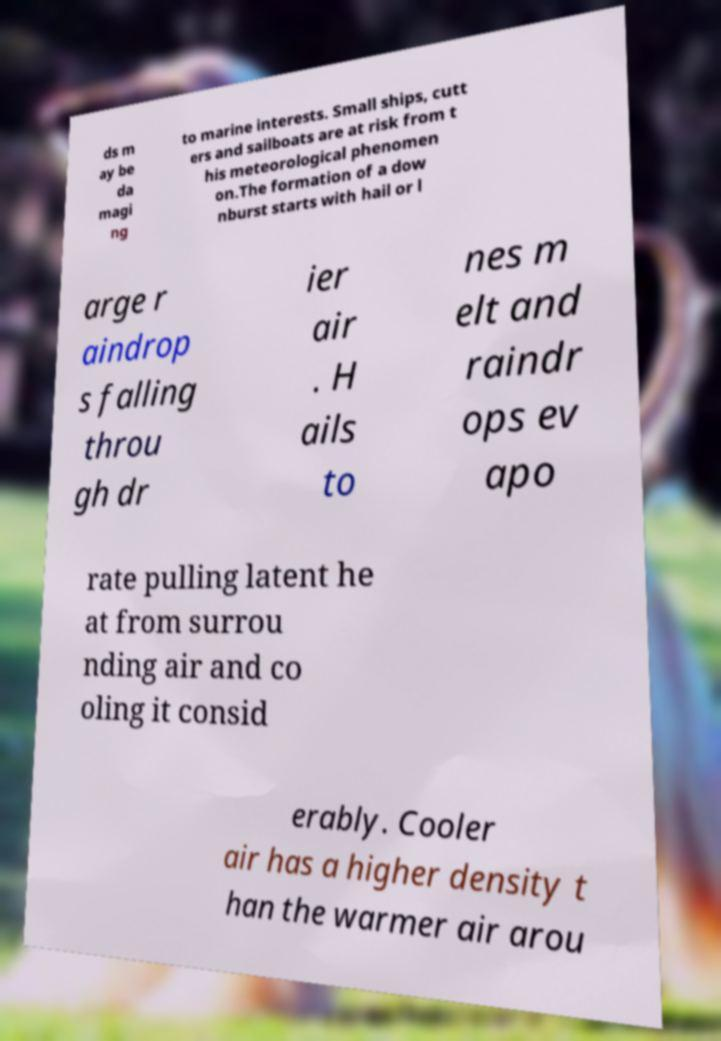For documentation purposes, I need the text within this image transcribed. Could you provide that? ds m ay be da magi ng to marine interests. Small ships, cutt ers and sailboats are at risk from t his meteorological phenomen on.The formation of a dow nburst starts with hail or l arge r aindrop s falling throu gh dr ier air . H ails to nes m elt and raindr ops ev apo rate pulling latent he at from surrou nding air and co oling it consid erably. Cooler air has a higher density t han the warmer air arou 